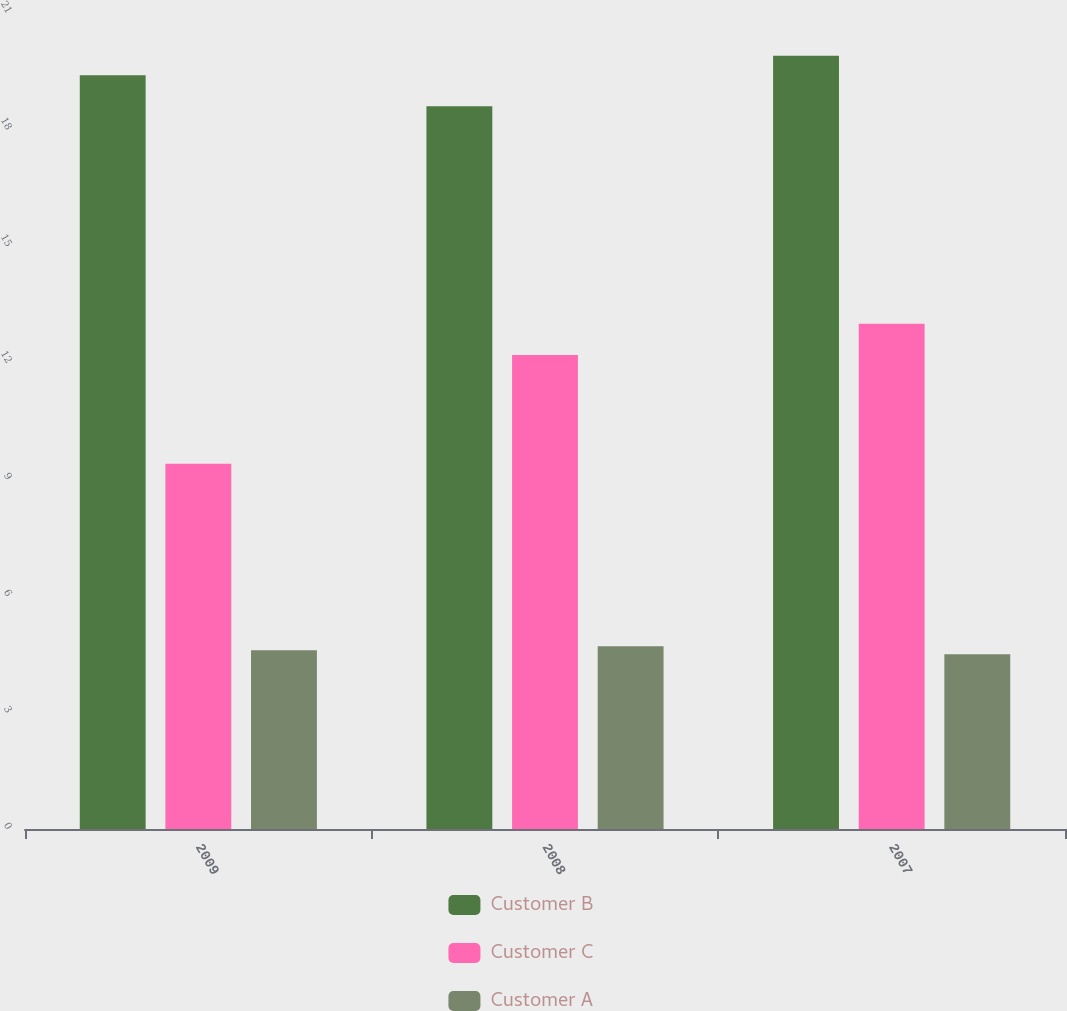Convert chart to OTSL. <chart><loc_0><loc_0><loc_500><loc_500><stacked_bar_chart><ecel><fcel>2009<fcel>2008<fcel>2007<nl><fcel>Customer B<fcel>19.4<fcel>18.6<fcel>19.9<nl><fcel>Customer C<fcel>9.4<fcel>12.2<fcel>13<nl><fcel>Customer A<fcel>4.6<fcel>4.7<fcel>4.5<nl></chart> 